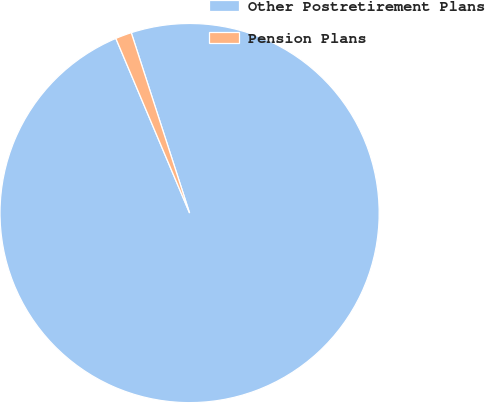Convert chart to OTSL. <chart><loc_0><loc_0><loc_500><loc_500><pie_chart><fcel>Other Postretirement Plans<fcel>Pension Plans<nl><fcel>98.62%<fcel>1.38%<nl></chart> 